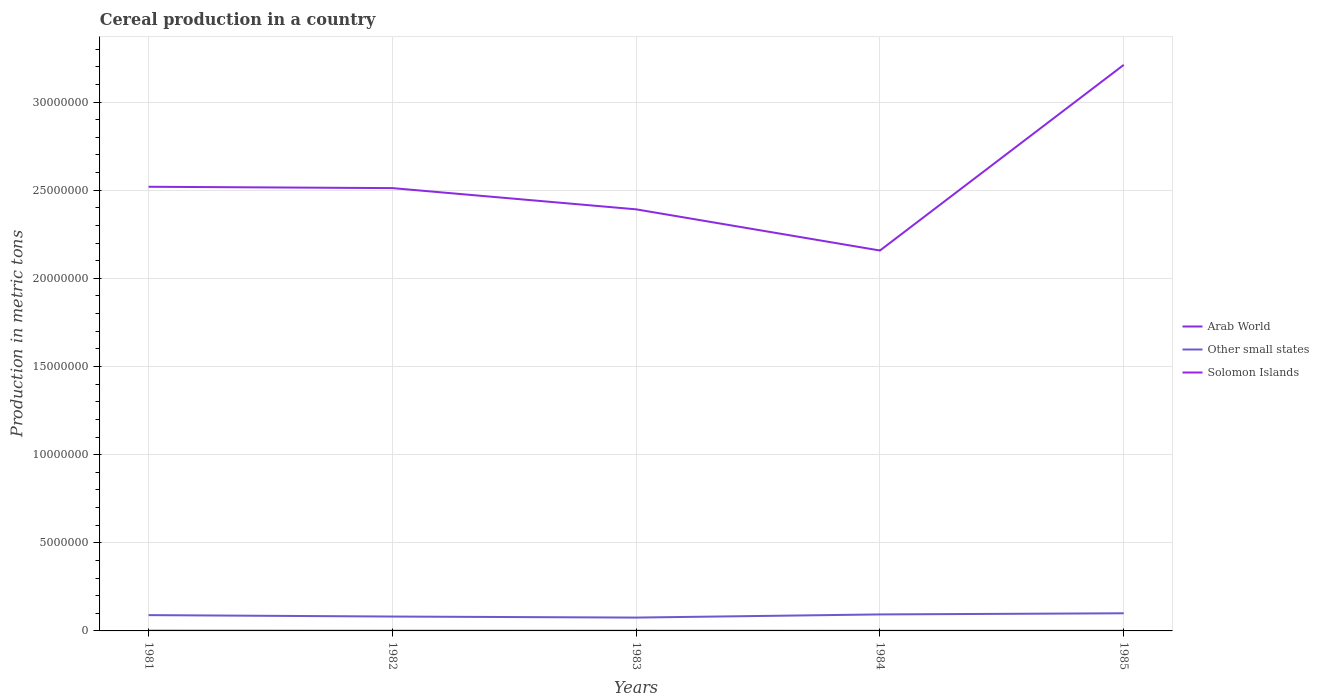How many different coloured lines are there?
Your answer should be compact. 3. Is the number of lines equal to the number of legend labels?
Give a very brief answer. Yes. Across all years, what is the maximum total cereal production in Other small states?
Make the answer very short. 7.57e+05. What is the total total cereal production in Other small states in the graph?
Offer a very short reply. -6.46e+04. What is the difference between the highest and the second highest total cereal production in Solomon Islands?
Give a very brief answer. 7912. What is the difference between the highest and the lowest total cereal production in Arab World?
Your response must be concise. 1. Is the total cereal production in Solomon Islands strictly greater than the total cereal production in Other small states over the years?
Your answer should be very brief. Yes. Where does the legend appear in the graph?
Ensure brevity in your answer.  Center right. What is the title of the graph?
Provide a succinct answer. Cereal production in a country. What is the label or title of the Y-axis?
Your answer should be compact. Production in metric tons. What is the Production in metric tons in Arab World in 1981?
Provide a short and direct response. 2.52e+07. What is the Production in metric tons of Other small states in 1981?
Your response must be concise. 8.97e+05. What is the Production in metric tons in Solomon Islands in 1981?
Ensure brevity in your answer.  1.39e+04. What is the Production in metric tons in Arab World in 1982?
Your answer should be very brief. 2.51e+07. What is the Production in metric tons in Other small states in 1982?
Your response must be concise. 8.15e+05. What is the Production in metric tons of Solomon Islands in 1982?
Ensure brevity in your answer.  1.05e+04. What is the Production in metric tons in Arab World in 1983?
Ensure brevity in your answer.  2.39e+07. What is the Production in metric tons in Other small states in 1983?
Offer a very short reply. 7.57e+05. What is the Production in metric tons in Solomon Islands in 1983?
Your answer should be very brief. 9481. What is the Production in metric tons of Arab World in 1984?
Keep it short and to the point. 2.16e+07. What is the Production in metric tons in Other small states in 1984?
Provide a succinct answer. 9.36e+05. What is the Production in metric tons in Solomon Islands in 1984?
Offer a terse response. 7137. What is the Production in metric tons in Arab World in 1985?
Provide a short and direct response. 3.21e+07. What is the Production in metric tons of Other small states in 1985?
Give a very brief answer. 1.00e+06. What is the Production in metric tons in Solomon Islands in 1985?
Offer a very short reply. 5954. Across all years, what is the maximum Production in metric tons of Arab World?
Provide a succinct answer. 3.21e+07. Across all years, what is the maximum Production in metric tons of Other small states?
Keep it short and to the point. 1.00e+06. Across all years, what is the maximum Production in metric tons of Solomon Islands?
Give a very brief answer. 1.39e+04. Across all years, what is the minimum Production in metric tons in Arab World?
Keep it short and to the point. 2.16e+07. Across all years, what is the minimum Production in metric tons in Other small states?
Your response must be concise. 7.57e+05. Across all years, what is the minimum Production in metric tons of Solomon Islands?
Provide a succinct answer. 5954. What is the total Production in metric tons of Arab World in the graph?
Make the answer very short. 1.28e+08. What is the total Production in metric tons in Other small states in the graph?
Offer a very short reply. 4.41e+06. What is the total Production in metric tons in Solomon Islands in the graph?
Your answer should be very brief. 4.70e+04. What is the difference between the Production in metric tons of Arab World in 1981 and that in 1982?
Ensure brevity in your answer.  7.64e+04. What is the difference between the Production in metric tons of Other small states in 1981 and that in 1982?
Keep it short and to the point. 8.18e+04. What is the difference between the Production in metric tons in Solomon Islands in 1981 and that in 1982?
Offer a terse response. 3328. What is the difference between the Production in metric tons of Arab World in 1981 and that in 1983?
Offer a terse response. 1.28e+06. What is the difference between the Production in metric tons of Other small states in 1981 and that in 1983?
Your response must be concise. 1.40e+05. What is the difference between the Production in metric tons in Solomon Islands in 1981 and that in 1983?
Offer a very short reply. 4385. What is the difference between the Production in metric tons of Arab World in 1981 and that in 1984?
Offer a terse response. 3.62e+06. What is the difference between the Production in metric tons of Other small states in 1981 and that in 1984?
Your answer should be very brief. -3.92e+04. What is the difference between the Production in metric tons in Solomon Islands in 1981 and that in 1984?
Keep it short and to the point. 6729. What is the difference between the Production in metric tons in Arab World in 1981 and that in 1985?
Your answer should be compact. -6.91e+06. What is the difference between the Production in metric tons in Other small states in 1981 and that in 1985?
Your answer should be very brief. -1.04e+05. What is the difference between the Production in metric tons of Solomon Islands in 1981 and that in 1985?
Provide a short and direct response. 7912. What is the difference between the Production in metric tons in Arab World in 1982 and that in 1983?
Offer a terse response. 1.20e+06. What is the difference between the Production in metric tons in Other small states in 1982 and that in 1983?
Your answer should be very brief. 5.80e+04. What is the difference between the Production in metric tons in Solomon Islands in 1982 and that in 1983?
Provide a short and direct response. 1057. What is the difference between the Production in metric tons of Arab World in 1982 and that in 1984?
Offer a terse response. 3.54e+06. What is the difference between the Production in metric tons in Other small states in 1982 and that in 1984?
Make the answer very short. -1.21e+05. What is the difference between the Production in metric tons in Solomon Islands in 1982 and that in 1984?
Keep it short and to the point. 3401. What is the difference between the Production in metric tons in Arab World in 1982 and that in 1985?
Your response must be concise. -6.99e+06. What is the difference between the Production in metric tons in Other small states in 1982 and that in 1985?
Offer a very short reply. -1.86e+05. What is the difference between the Production in metric tons of Solomon Islands in 1982 and that in 1985?
Your response must be concise. 4584. What is the difference between the Production in metric tons in Arab World in 1983 and that in 1984?
Your answer should be very brief. 2.34e+06. What is the difference between the Production in metric tons of Other small states in 1983 and that in 1984?
Make the answer very short. -1.79e+05. What is the difference between the Production in metric tons in Solomon Islands in 1983 and that in 1984?
Provide a succinct answer. 2344. What is the difference between the Production in metric tons in Arab World in 1983 and that in 1985?
Your answer should be compact. -8.19e+06. What is the difference between the Production in metric tons of Other small states in 1983 and that in 1985?
Make the answer very short. -2.44e+05. What is the difference between the Production in metric tons of Solomon Islands in 1983 and that in 1985?
Ensure brevity in your answer.  3527. What is the difference between the Production in metric tons of Arab World in 1984 and that in 1985?
Your response must be concise. -1.05e+07. What is the difference between the Production in metric tons in Other small states in 1984 and that in 1985?
Offer a terse response. -6.46e+04. What is the difference between the Production in metric tons in Solomon Islands in 1984 and that in 1985?
Your answer should be very brief. 1183. What is the difference between the Production in metric tons in Arab World in 1981 and the Production in metric tons in Other small states in 1982?
Offer a terse response. 2.44e+07. What is the difference between the Production in metric tons of Arab World in 1981 and the Production in metric tons of Solomon Islands in 1982?
Ensure brevity in your answer.  2.52e+07. What is the difference between the Production in metric tons of Other small states in 1981 and the Production in metric tons of Solomon Islands in 1982?
Your response must be concise. 8.86e+05. What is the difference between the Production in metric tons of Arab World in 1981 and the Production in metric tons of Other small states in 1983?
Your answer should be compact. 2.44e+07. What is the difference between the Production in metric tons in Arab World in 1981 and the Production in metric tons in Solomon Islands in 1983?
Your response must be concise. 2.52e+07. What is the difference between the Production in metric tons in Other small states in 1981 and the Production in metric tons in Solomon Islands in 1983?
Offer a very short reply. 8.87e+05. What is the difference between the Production in metric tons of Arab World in 1981 and the Production in metric tons of Other small states in 1984?
Offer a very short reply. 2.43e+07. What is the difference between the Production in metric tons of Arab World in 1981 and the Production in metric tons of Solomon Islands in 1984?
Keep it short and to the point. 2.52e+07. What is the difference between the Production in metric tons in Other small states in 1981 and the Production in metric tons in Solomon Islands in 1984?
Your response must be concise. 8.90e+05. What is the difference between the Production in metric tons of Arab World in 1981 and the Production in metric tons of Other small states in 1985?
Ensure brevity in your answer.  2.42e+07. What is the difference between the Production in metric tons in Arab World in 1981 and the Production in metric tons in Solomon Islands in 1985?
Offer a terse response. 2.52e+07. What is the difference between the Production in metric tons in Other small states in 1981 and the Production in metric tons in Solomon Islands in 1985?
Offer a terse response. 8.91e+05. What is the difference between the Production in metric tons in Arab World in 1982 and the Production in metric tons in Other small states in 1983?
Your answer should be compact. 2.44e+07. What is the difference between the Production in metric tons of Arab World in 1982 and the Production in metric tons of Solomon Islands in 1983?
Ensure brevity in your answer.  2.51e+07. What is the difference between the Production in metric tons in Other small states in 1982 and the Production in metric tons in Solomon Islands in 1983?
Offer a terse response. 8.06e+05. What is the difference between the Production in metric tons of Arab World in 1982 and the Production in metric tons of Other small states in 1984?
Your answer should be very brief. 2.42e+07. What is the difference between the Production in metric tons in Arab World in 1982 and the Production in metric tons in Solomon Islands in 1984?
Keep it short and to the point. 2.51e+07. What is the difference between the Production in metric tons of Other small states in 1982 and the Production in metric tons of Solomon Islands in 1984?
Provide a succinct answer. 8.08e+05. What is the difference between the Production in metric tons of Arab World in 1982 and the Production in metric tons of Other small states in 1985?
Provide a short and direct response. 2.41e+07. What is the difference between the Production in metric tons of Arab World in 1982 and the Production in metric tons of Solomon Islands in 1985?
Provide a short and direct response. 2.51e+07. What is the difference between the Production in metric tons in Other small states in 1982 and the Production in metric tons in Solomon Islands in 1985?
Provide a succinct answer. 8.09e+05. What is the difference between the Production in metric tons in Arab World in 1983 and the Production in metric tons in Other small states in 1984?
Offer a very short reply. 2.30e+07. What is the difference between the Production in metric tons of Arab World in 1983 and the Production in metric tons of Solomon Islands in 1984?
Your answer should be compact. 2.39e+07. What is the difference between the Production in metric tons in Other small states in 1983 and the Production in metric tons in Solomon Islands in 1984?
Your answer should be compact. 7.50e+05. What is the difference between the Production in metric tons of Arab World in 1983 and the Production in metric tons of Other small states in 1985?
Make the answer very short. 2.29e+07. What is the difference between the Production in metric tons of Arab World in 1983 and the Production in metric tons of Solomon Islands in 1985?
Offer a very short reply. 2.39e+07. What is the difference between the Production in metric tons in Other small states in 1983 and the Production in metric tons in Solomon Islands in 1985?
Keep it short and to the point. 7.51e+05. What is the difference between the Production in metric tons in Arab World in 1984 and the Production in metric tons in Other small states in 1985?
Your answer should be very brief. 2.06e+07. What is the difference between the Production in metric tons of Arab World in 1984 and the Production in metric tons of Solomon Islands in 1985?
Offer a very short reply. 2.16e+07. What is the difference between the Production in metric tons of Other small states in 1984 and the Production in metric tons of Solomon Islands in 1985?
Your answer should be compact. 9.30e+05. What is the average Production in metric tons in Arab World per year?
Your answer should be compact. 2.56e+07. What is the average Production in metric tons in Other small states per year?
Provide a short and direct response. 8.81e+05. What is the average Production in metric tons of Solomon Islands per year?
Offer a terse response. 9395.2. In the year 1981, what is the difference between the Production in metric tons of Arab World and Production in metric tons of Other small states?
Your answer should be very brief. 2.43e+07. In the year 1981, what is the difference between the Production in metric tons in Arab World and Production in metric tons in Solomon Islands?
Offer a terse response. 2.52e+07. In the year 1981, what is the difference between the Production in metric tons in Other small states and Production in metric tons in Solomon Islands?
Provide a short and direct response. 8.83e+05. In the year 1982, what is the difference between the Production in metric tons of Arab World and Production in metric tons of Other small states?
Offer a very short reply. 2.43e+07. In the year 1982, what is the difference between the Production in metric tons of Arab World and Production in metric tons of Solomon Islands?
Your response must be concise. 2.51e+07. In the year 1982, what is the difference between the Production in metric tons of Other small states and Production in metric tons of Solomon Islands?
Offer a terse response. 8.04e+05. In the year 1983, what is the difference between the Production in metric tons of Arab World and Production in metric tons of Other small states?
Your answer should be compact. 2.32e+07. In the year 1983, what is the difference between the Production in metric tons of Arab World and Production in metric tons of Solomon Islands?
Your answer should be compact. 2.39e+07. In the year 1983, what is the difference between the Production in metric tons of Other small states and Production in metric tons of Solomon Islands?
Keep it short and to the point. 7.48e+05. In the year 1984, what is the difference between the Production in metric tons in Arab World and Production in metric tons in Other small states?
Offer a terse response. 2.06e+07. In the year 1984, what is the difference between the Production in metric tons in Arab World and Production in metric tons in Solomon Islands?
Ensure brevity in your answer.  2.16e+07. In the year 1984, what is the difference between the Production in metric tons in Other small states and Production in metric tons in Solomon Islands?
Your answer should be compact. 9.29e+05. In the year 1985, what is the difference between the Production in metric tons in Arab World and Production in metric tons in Other small states?
Keep it short and to the point. 3.11e+07. In the year 1985, what is the difference between the Production in metric tons of Arab World and Production in metric tons of Solomon Islands?
Provide a short and direct response. 3.21e+07. In the year 1985, what is the difference between the Production in metric tons of Other small states and Production in metric tons of Solomon Islands?
Provide a succinct answer. 9.95e+05. What is the ratio of the Production in metric tons of Other small states in 1981 to that in 1982?
Offer a very short reply. 1.1. What is the ratio of the Production in metric tons of Solomon Islands in 1981 to that in 1982?
Provide a succinct answer. 1.32. What is the ratio of the Production in metric tons in Arab World in 1981 to that in 1983?
Offer a very short reply. 1.05. What is the ratio of the Production in metric tons in Other small states in 1981 to that in 1983?
Make the answer very short. 1.18. What is the ratio of the Production in metric tons in Solomon Islands in 1981 to that in 1983?
Ensure brevity in your answer.  1.46. What is the ratio of the Production in metric tons in Arab World in 1981 to that in 1984?
Offer a terse response. 1.17. What is the ratio of the Production in metric tons of Other small states in 1981 to that in 1984?
Your answer should be compact. 0.96. What is the ratio of the Production in metric tons of Solomon Islands in 1981 to that in 1984?
Offer a terse response. 1.94. What is the ratio of the Production in metric tons in Arab World in 1981 to that in 1985?
Keep it short and to the point. 0.78. What is the ratio of the Production in metric tons in Other small states in 1981 to that in 1985?
Your answer should be very brief. 0.9. What is the ratio of the Production in metric tons in Solomon Islands in 1981 to that in 1985?
Your answer should be compact. 2.33. What is the ratio of the Production in metric tons in Arab World in 1982 to that in 1983?
Keep it short and to the point. 1.05. What is the ratio of the Production in metric tons of Other small states in 1982 to that in 1983?
Offer a terse response. 1.08. What is the ratio of the Production in metric tons in Solomon Islands in 1982 to that in 1983?
Keep it short and to the point. 1.11. What is the ratio of the Production in metric tons of Arab World in 1982 to that in 1984?
Offer a terse response. 1.16. What is the ratio of the Production in metric tons of Other small states in 1982 to that in 1984?
Give a very brief answer. 0.87. What is the ratio of the Production in metric tons of Solomon Islands in 1982 to that in 1984?
Provide a short and direct response. 1.48. What is the ratio of the Production in metric tons in Arab World in 1982 to that in 1985?
Give a very brief answer. 0.78. What is the ratio of the Production in metric tons of Other small states in 1982 to that in 1985?
Ensure brevity in your answer.  0.81. What is the ratio of the Production in metric tons in Solomon Islands in 1982 to that in 1985?
Your answer should be very brief. 1.77. What is the ratio of the Production in metric tons in Arab World in 1983 to that in 1984?
Keep it short and to the point. 1.11. What is the ratio of the Production in metric tons of Other small states in 1983 to that in 1984?
Make the answer very short. 0.81. What is the ratio of the Production in metric tons of Solomon Islands in 1983 to that in 1984?
Offer a terse response. 1.33. What is the ratio of the Production in metric tons in Arab World in 1983 to that in 1985?
Ensure brevity in your answer.  0.74. What is the ratio of the Production in metric tons in Other small states in 1983 to that in 1985?
Your answer should be very brief. 0.76. What is the ratio of the Production in metric tons in Solomon Islands in 1983 to that in 1985?
Your response must be concise. 1.59. What is the ratio of the Production in metric tons of Arab World in 1984 to that in 1985?
Your answer should be very brief. 0.67. What is the ratio of the Production in metric tons of Other small states in 1984 to that in 1985?
Keep it short and to the point. 0.94. What is the ratio of the Production in metric tons in Solomon Islands in 1984 to that in 1985?
Ensure brevity in your answer.  1.2. What is the difference between the highest and the second highest Production in metric tons of Arab World?
Offer a terse response. 6.91e+06. What is the difference between the highest and the second highest Production in metric tons in Other small states?
Provide a succinct answer. 6.46e+04. What is the difference between the highest and the second highest Production in metric tons in Solomon Islands?
Offer a very short reply. 3328. What is the difference between the highest and the lowest Production in metric tons of Arab World?
Your answer should be very brief. 1.05e+07. What is the difference between the highest and the lowest Production in metric tons in Other small states?
Your response must be concise. 2.44e+05. What is the difference between the highest and the lowest Production in metric tons of Solomon Islands?
Give a very brief answer. 7912. 